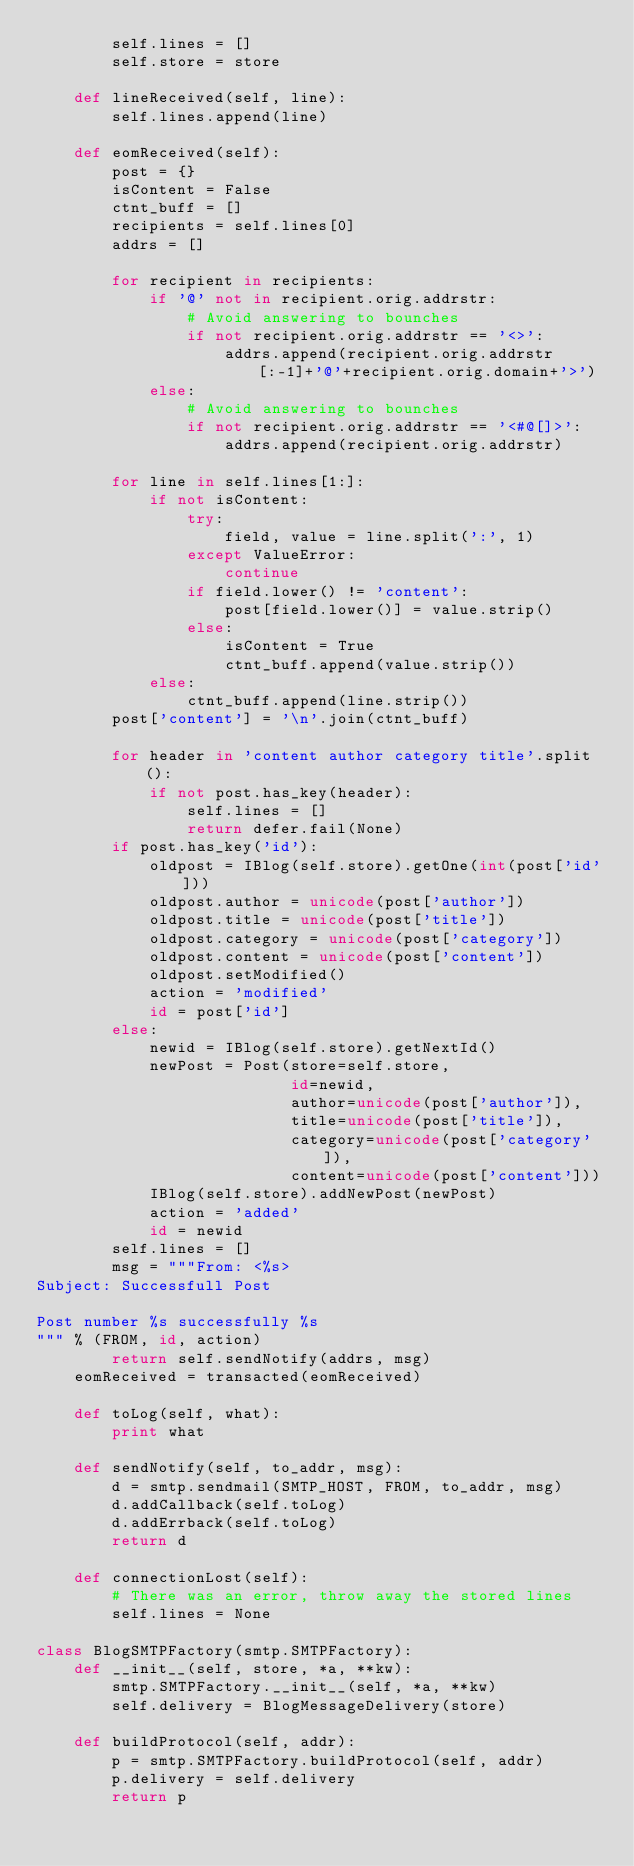<code> <loc_0><loc_0><loc_500><loc_500><_Python_>        self.lines = []
        self.store = store
    
    def lineReceived(self, line):
        self.lines.append(line)
    
    def eomReceived(self):
        post = {}
        isContent = False
        ctnt_buff = []
        recipients = self.lines[0]
        addrs = []

        for recipient in recipients:
            if '@' not in recipient.orig.addrstr:
                # Avoid answering to bounches
                if not recipient.orig.addrstr == '<>':
                    addrs.append(recipient.orig.addrstr[:-1]+'@'+recipient.orig.domain+'>')
            else:
                # Avoid answering to bounches
                if not recipient.orig.addrstr == '<#@[]>':
                    addrs.append(recipient.orig.addrstr)
            
        for line in self.lines[1:]:
            if not isContent:
                try:
                    field, value = line.split(':', 1)
                except ValueError:
                    continue
                if field.lower() != 'content':
                    post[field.lower()] = value.strip()
                else: 
                    isContent = True
                    ctnt_buff.append(value.strip())
            else:
                ctnt_buff.append(line.strip())
        post['content'] = '\n'.join(ctnt_buff)
        
        for header in 'content author category title'.split():
            if not post.has_key(header):
                self.lines = []
                return defer.fail(None) 
        if post.has_key('id'):
            oldpost = IBlog(self.store).getOne(int(post['id']))
            oldpost.author = unicode(post['author'])
            oldpost.title = unicode(post['title'])
            oldpost.category = unicode(post['category'])
            oldpost.content = unicode(post['content'])
            oldpost.setModified()
            action = 'modified'
            id = post['id']
        else:
            newid = IBlog(self.store).getNextId()
            newPost = Post(store=self.store,
                           id=newid,
                           author=unicode(post['author']),
                           title=unicode(post['title']),
                           category=unicode(post['category']),
                           content=unicode(post['content']))
            IBlog(self.store).addNewPost(newPost)
            action = 'added'
            id = newid
        self.lines = []
        msg = """From: <%s>
Subject: Successfull Post

Post number %s successfully %s
""" % (FROM, id, action)
        return self.sendNotify(addrs, msg)
    eomReceived = transacted(eomReceived)
    
    def toLog(self, what):
        print what
        
    def sendNotify(self, to_addr, msg):
        d = smtp.sendmail(SMTP_HOST, FROM, to_addr, msg)
        d.addCallback(self.toLog)
        d.addErrback(self.toLog)
        return d
    
    def connectionLost(self):
        # There was an error, throw away the stored lines
        self.lines = None

class BlogSMTPFactory(smtp.SMTPFactory):
    def __init__(self, store, *a, **kw):
        smtp.SMTPFactory.__init__(self, *a, **kw)
        self.delivery = BlogMessageDelivery(store)
    
    def buildProtocol(self, addr):
        p = smtp.SMTPFactory.buildProtocol(self, addr)
        p.delivery = self.delivery
        return p
</code> 